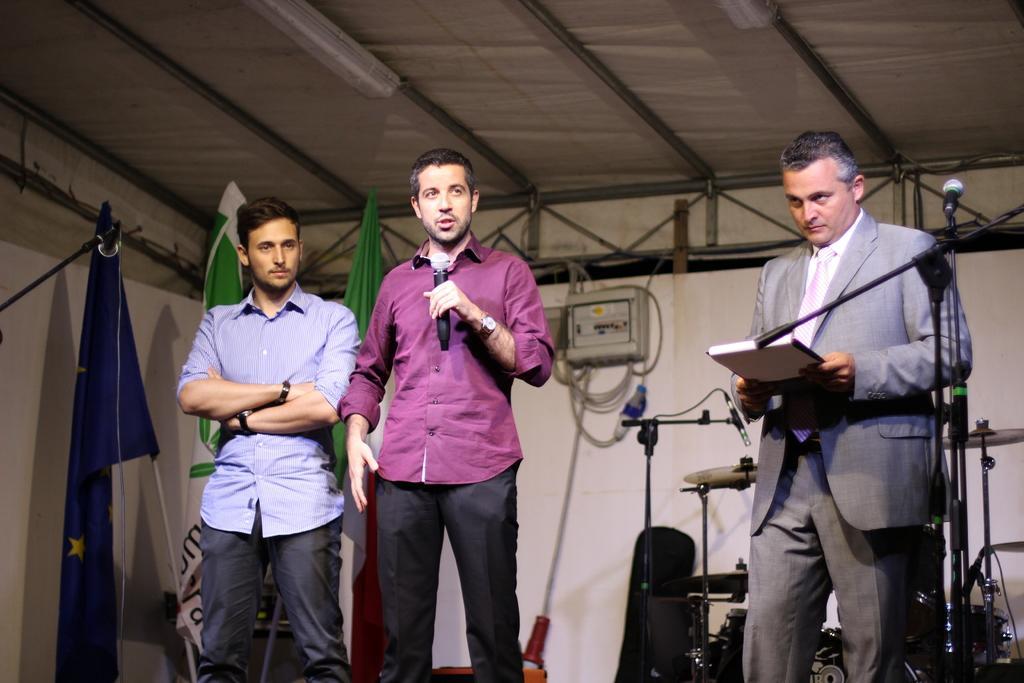Please provide a concise description of this image. There are three persons standing on the floor. He is talking on the mike and he is holding a book with his hand. On the background there is a wall and there are flags. This is light and there is a roof. 